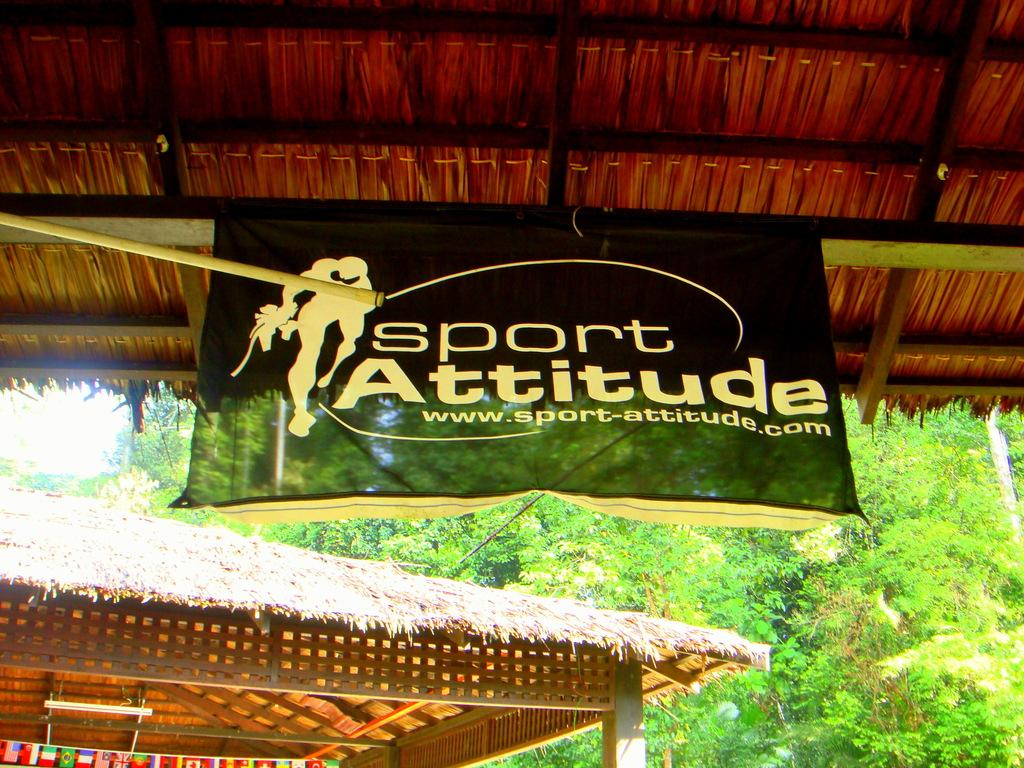What type of structures are visible in the image? There are huts in the image. Can you describe any specific features of the huts? A banner is tied to the roof of a hut in the front. What can be seen in the background of the image? There are trees in the background of the image. What type of drink is being served in the huts in the image? There is no indication of any drinks being served in the image; it only shows huts with a banner on one of them and trees in the background. 